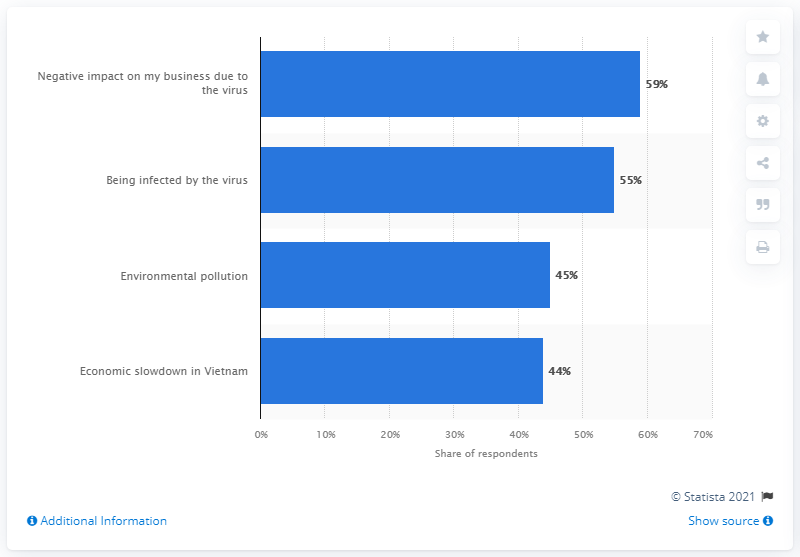Mention a couple of crucial points in this snapshot. According to a survey conducted in Vietnam, 59% of consumers reported that the COVID-19 pandemic had a negative impact on their business. 